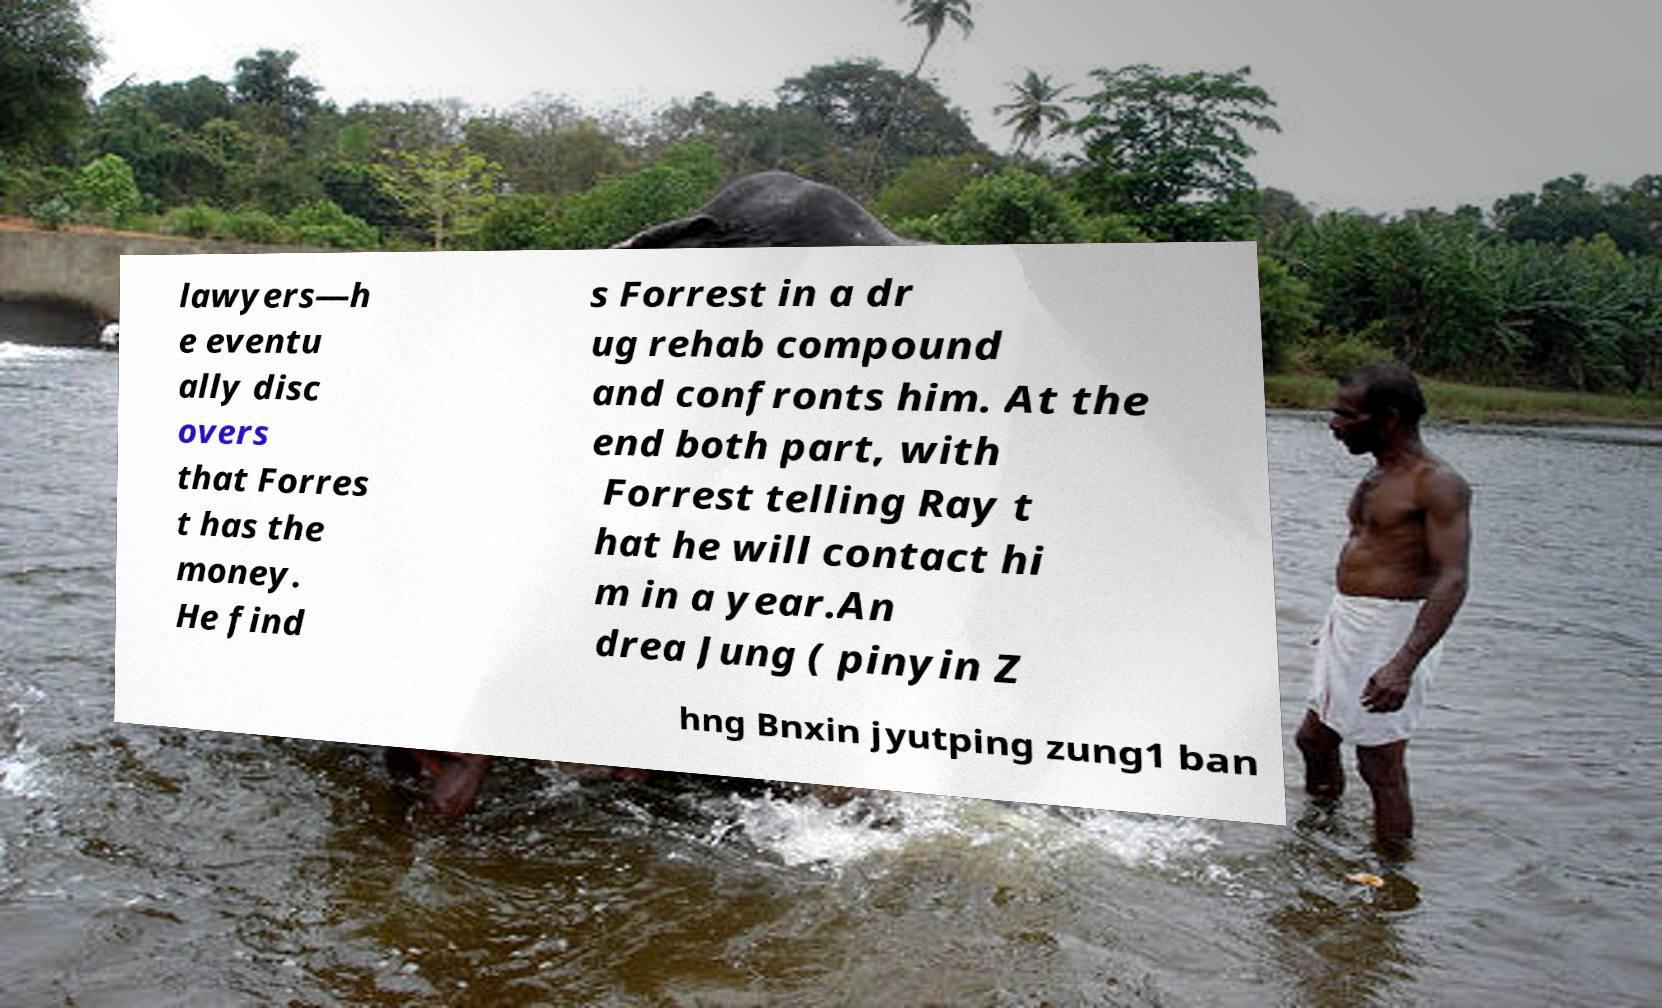For documentation purposes, I need the text within this image transcribed. Could you provide that? lawyers—h e eventu ally disc overs that Forres t has the money. He find s Forrest in a dr ug rehab compound and confronts him. At the end both part, with Forrest telling Ray t hat he will contact hi m in a year.An drea Jung ( pinyin Z hng Bnxin jyutping zung1 ban 